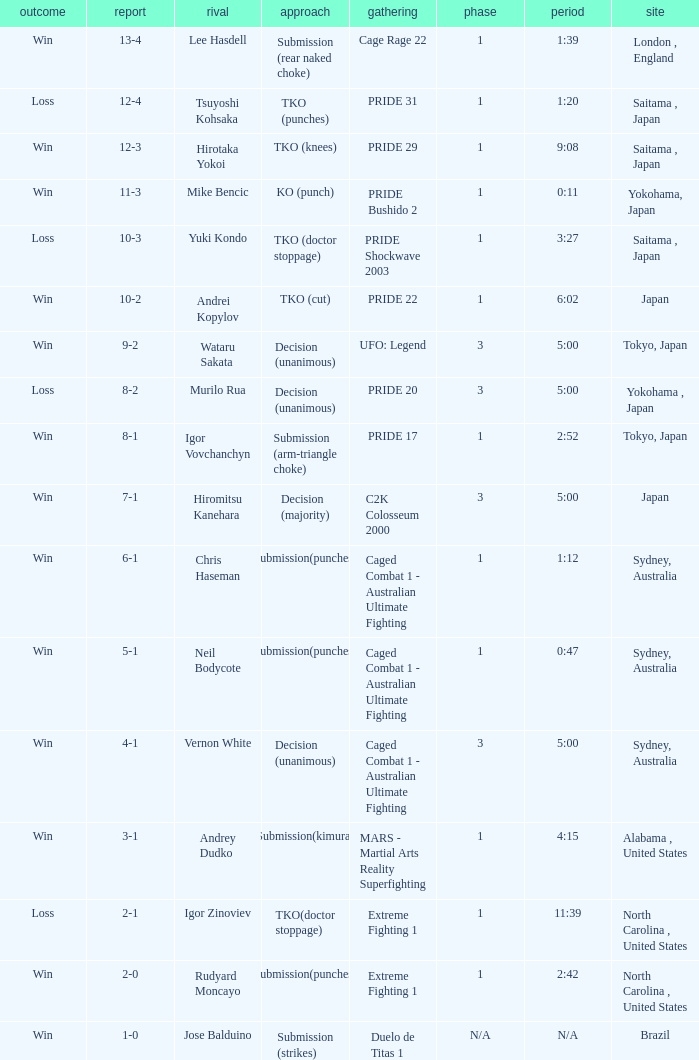Which Record has the Res of win with the Event of extreme fighting 1? 2-0. 